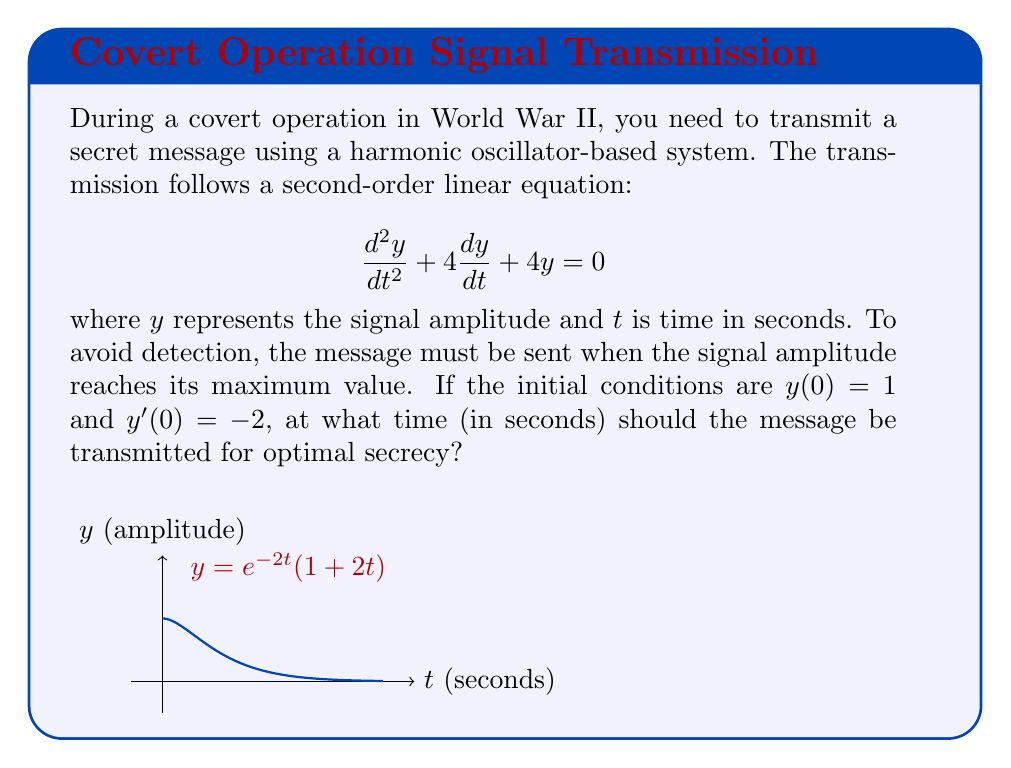Provide a solution to this math problem. To solve this problem, we follow these steps:

1) The characteristic equation for this second-order linear equation is:
   $$r^2 + 4r + 4 = 0$$

2) Solving this equation:
   $$(r+2)^2 = 0$$
   $$r = -2$$ (repeated root)

3) The general solution is therefore:
   $$y = e^{-2t}(c_1 + c_2t)$$

4) Using the initial conditions:
   $y(0) = 1$, so $c_1 = 1$
   $y'(0) = -2$, so $-2c_1 + c_2 = -2$
   Solving this, we get $c_2 = 2$

5) Therefore, the particular solution is:
   $$y = e^{-2t}(1 + 2t)$$

6) To find the maximum, we differentiate and set to zero:
   $$\frac{dy}{dt} = e^{-2t}(-2-4t+2) = e^{-2t}(-4t)$$

7) Setting this to zero:
   $$e^{-2t}(-4t) = 0$$
   $$t = 0$$ or $$e^{-2t} = 0$$

8) Since $e^{-2t}$ is never zero, the only critical point is at $t = 0.5$ seconds.

9) Checking the second derivative confirms this is a maximum.

Therefore, the optimal time to transmit the message is 0.5 seconds after the initial time.
Answer: 0.5 seconds 